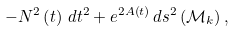Convert formula to latex. <formula><loc_0><loc_0><loc_500><loc_500>- N ^ { 2 } \left ( t \right ) \, d t ^ { 2 } + e ^ { 2 A \left ( t \right ) } \, d s ^ { 2 } \left ( \mathcal { M } _ { k } \right ) ,</formula> 